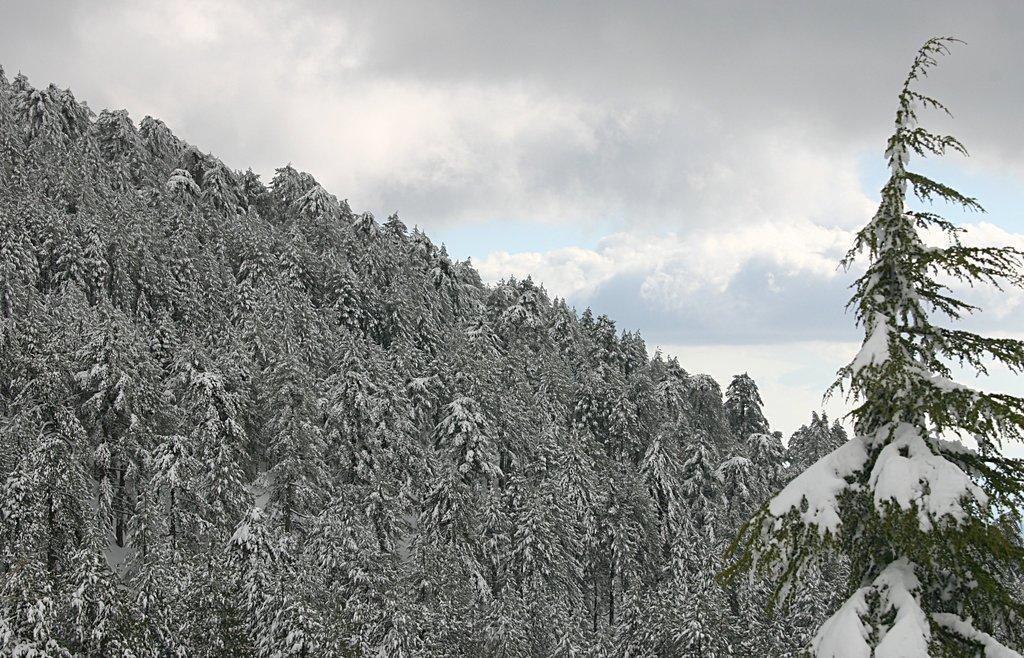How would you summarize this image in a sentence or two? In this picture we can observe some trees. There is some snow on the trees. In the background there is a sky with some clouds. 